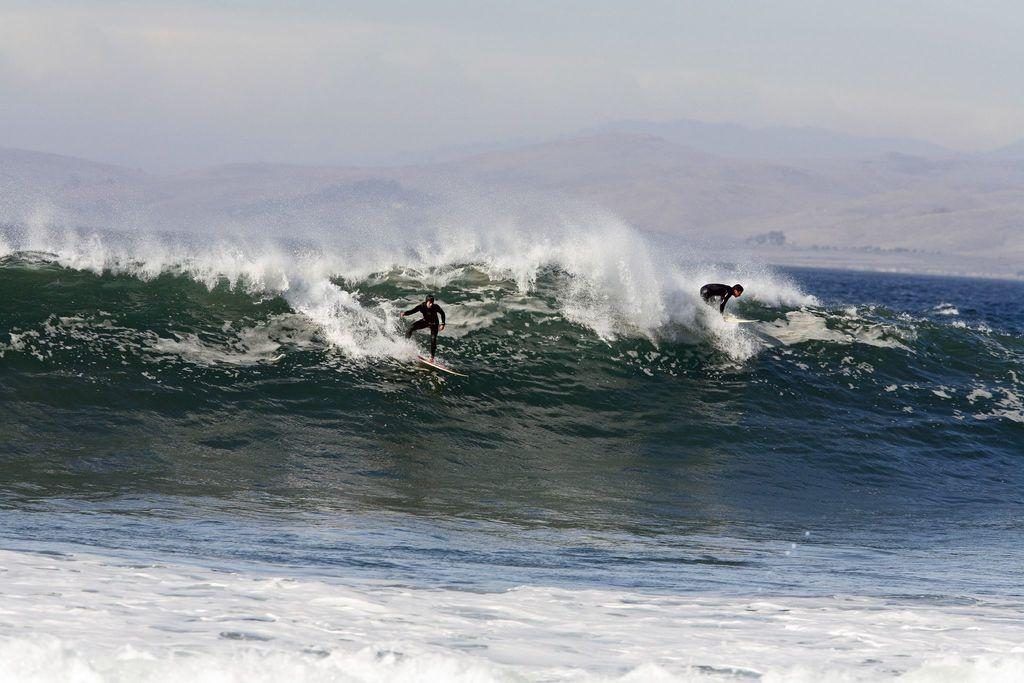What type of natural body of water is present in the image? There is a sea in the image. What are the two persons in the image doing? They are on surfboards in the image. What type of landform can be seen in the distance? There are mountains visible in the image. What is visible above the sea and mountains? The sky is visible in the image. What type of soap is being used by the persons on the surfboards in the image? There is no soap present in the image; the persons are on surfboards in the sea. 